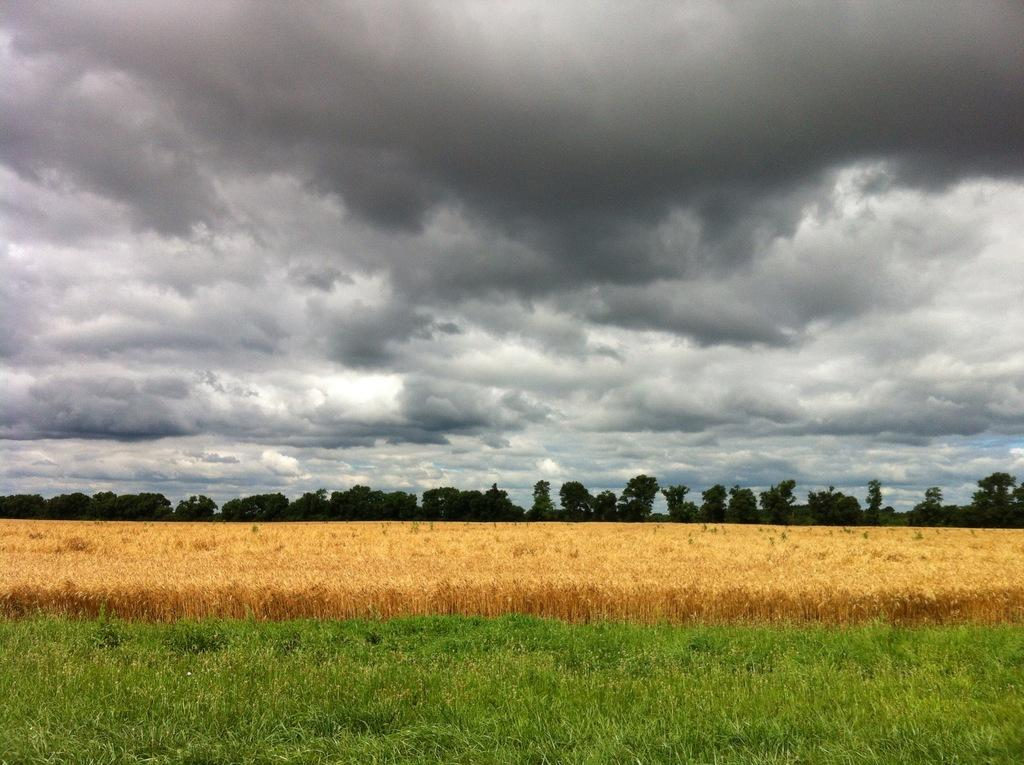What type of surface is visible in the image? There is grass on the surface in the image. What can be seen in the background of the image? There are trees and the sky visible in the background of the image. What type of drug can be seen growing in the grass in the image? There is no drug present in the image; it features grass on the surface with trees and the sky in the background. 